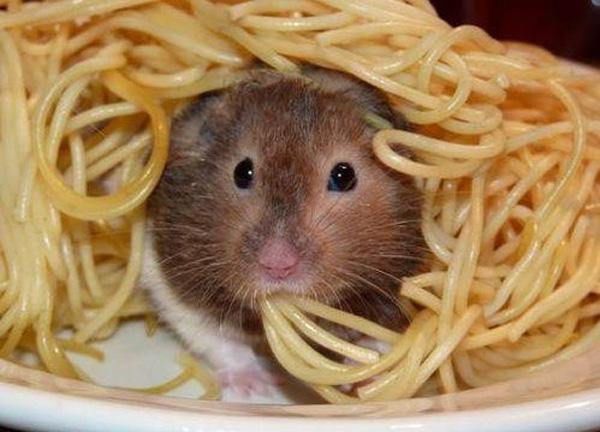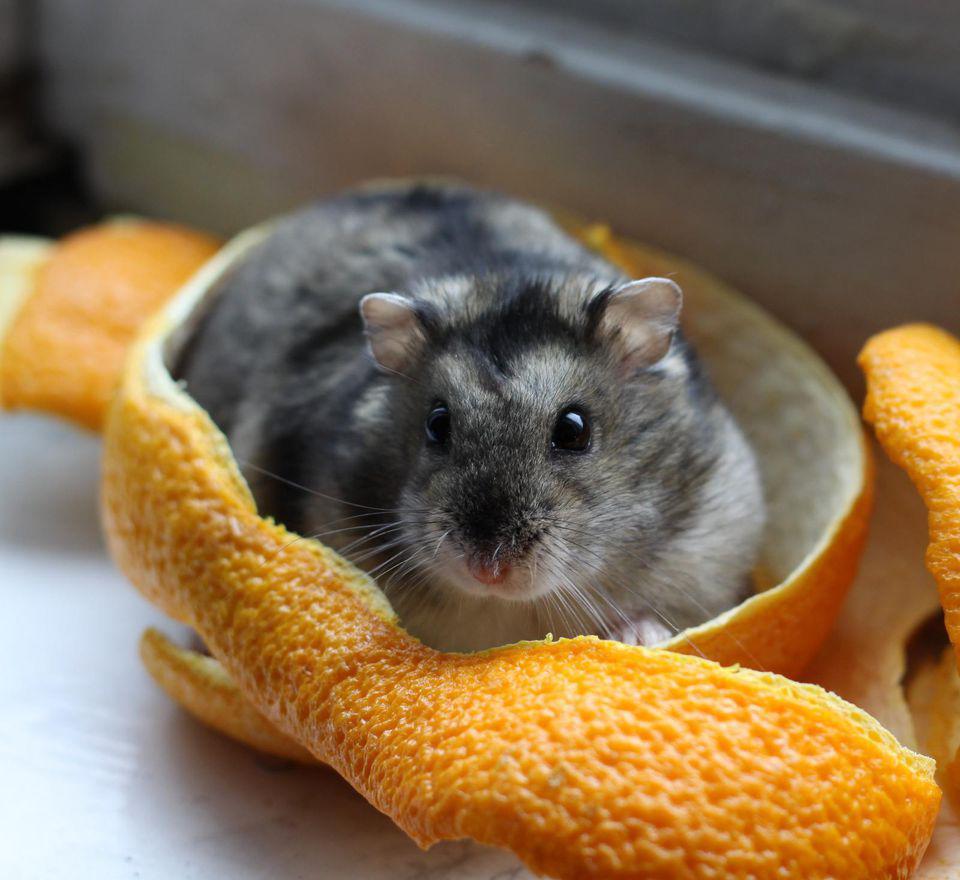The first image is the image on the left, the second image is the image on the right. Analyze the images presented: Is the assertion "One image shows at least one pet rodent on shredded bedding material, and the other image shows a hand holding no more than two pet rodents." valid? Answer yes or no. No. The first image is the image on the left, the second image is the image on the right. Considering the images on both sides, is "There are at least five animals in total." valid? Answer yes or no. No. 